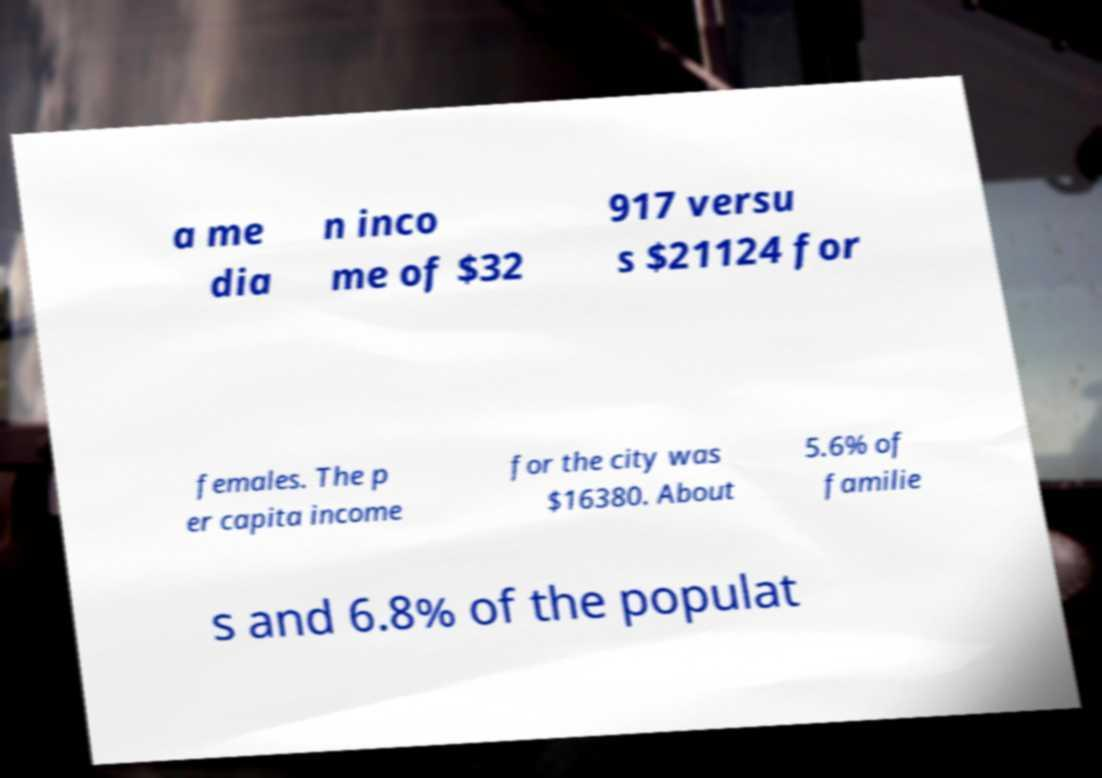Please identify and transcribe the text found in this image. a me dia n inco me of $32 917 versu s $21124 for females. The p er capita income for the city was $16380. About 5.6% of familie s and 6.8% of the populat 